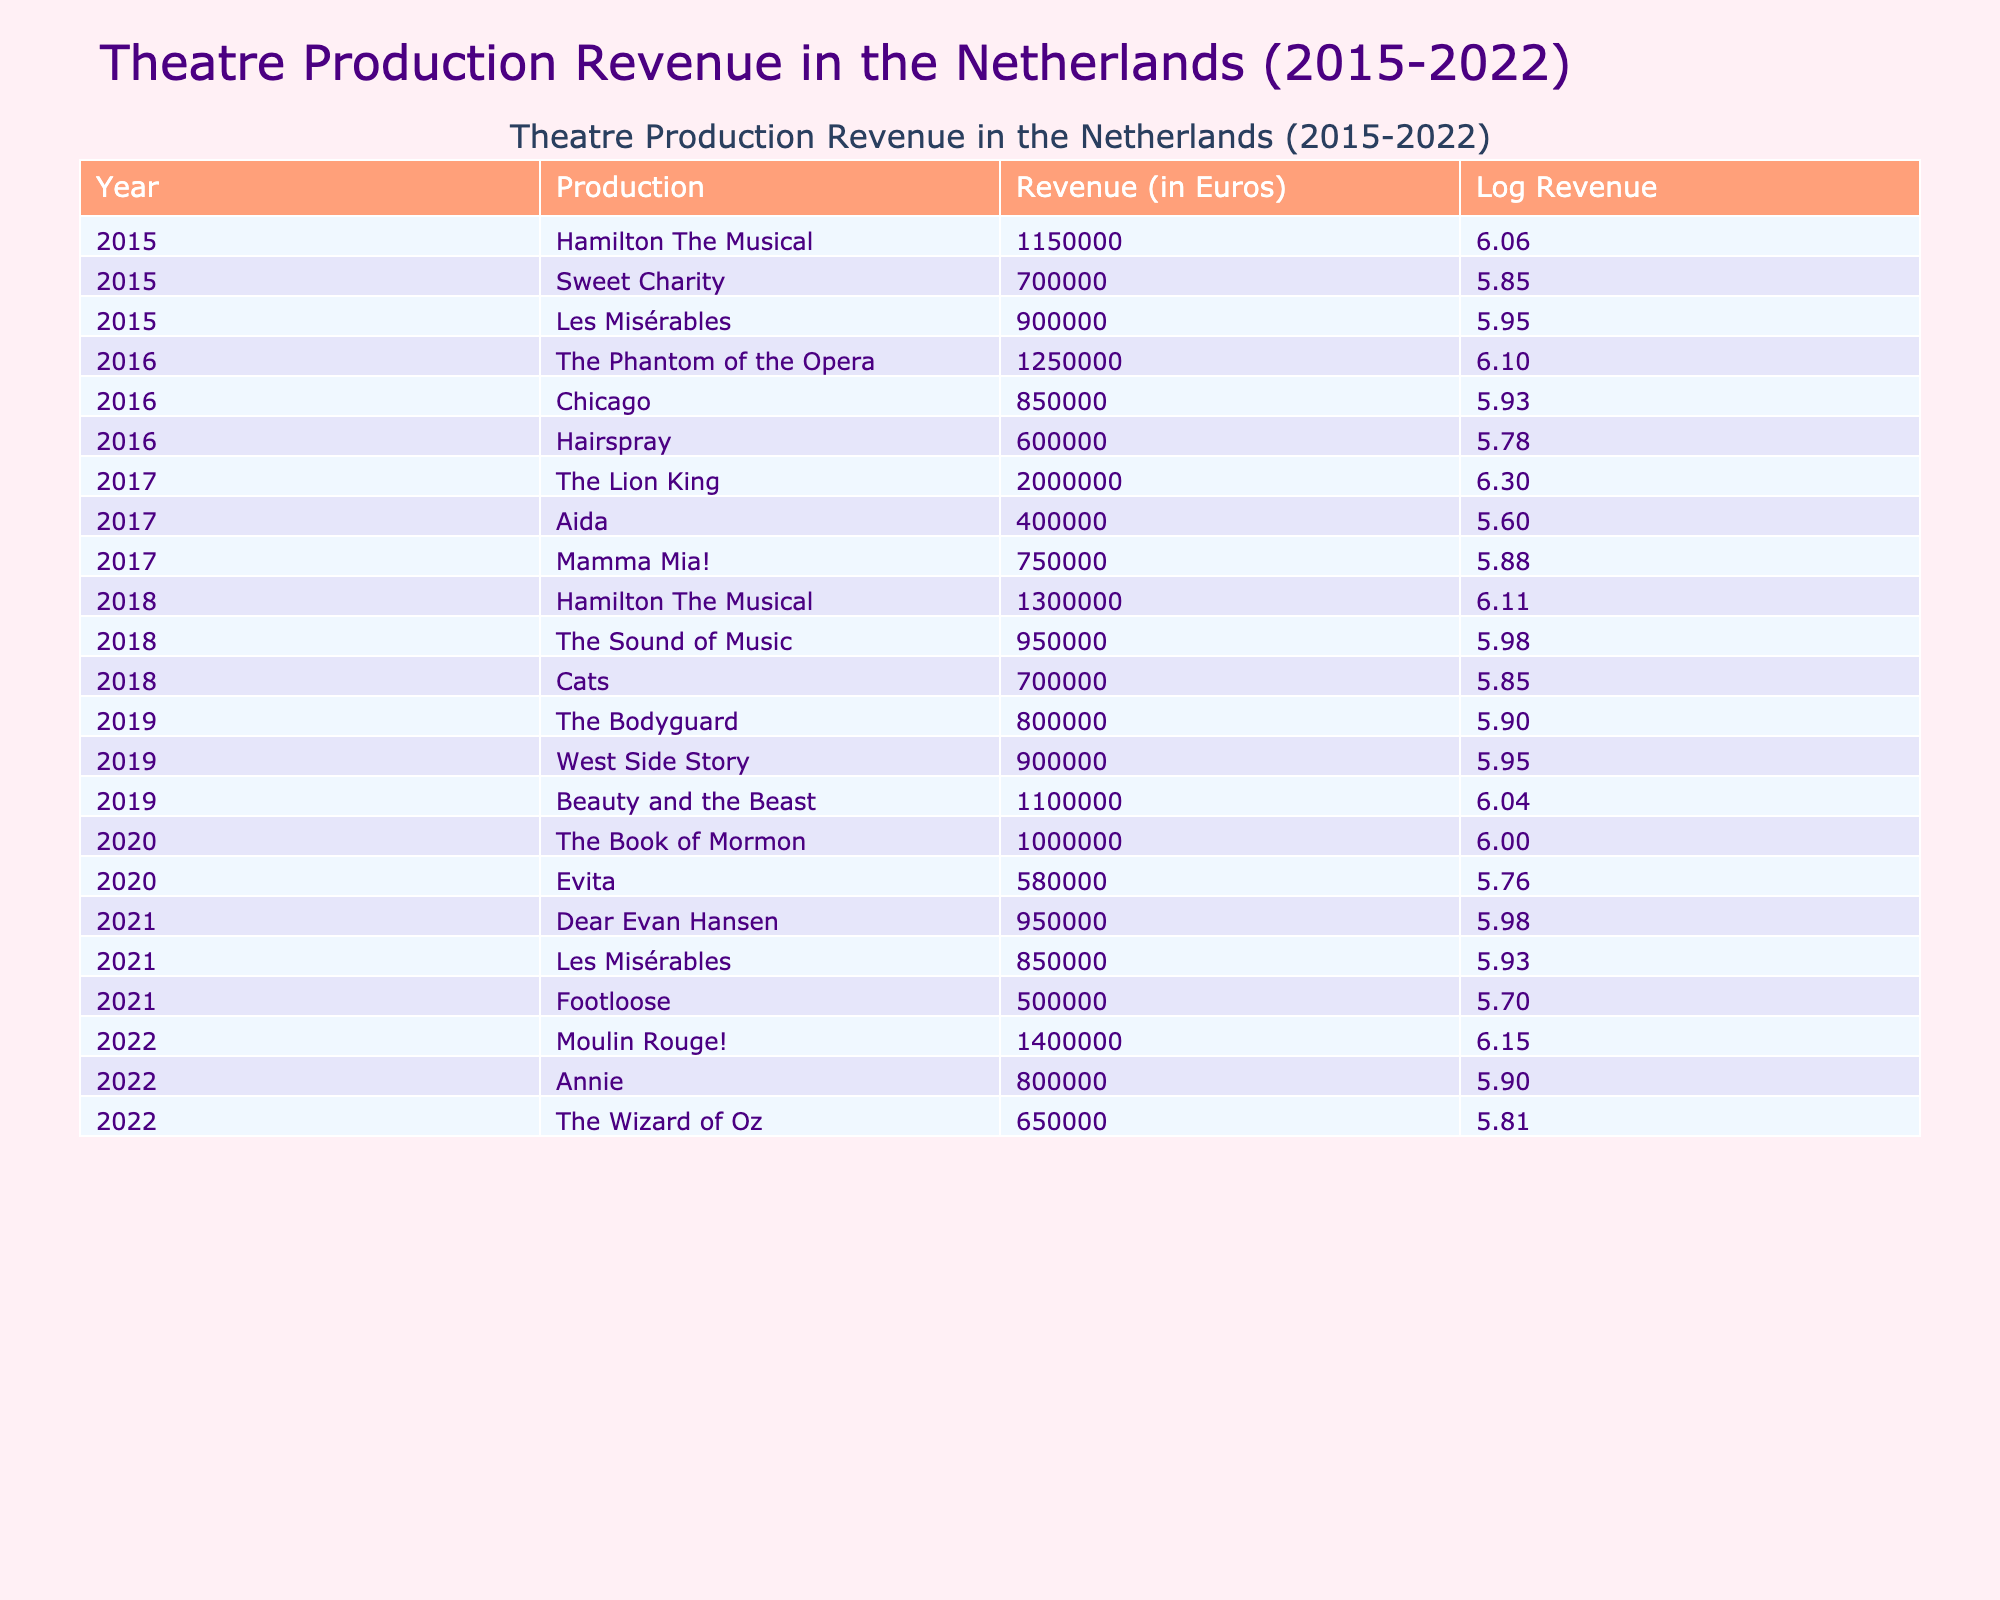What was the highest revenue generated by a single production in 2017? The productions listed for 2017 are The Lion King (2,000,000), Aida (400,000), and Mamma Mia! (750,000). The highest revenue among these is from The Lion King with 2,000,000 Euros.
Answer: 2,000,000 What was the total revenue generated from all productions in 2019? The productions in 2019 and their revenues are The Bodyguard (800,000), West Side Story (900,000), and Beauty and the Beast (1,100,000). Adding these together: 800,000 + 900,000 + 1,100,000 = 2,800,000 Euros.
Answer: 2,800,000 Which year had the lowest revenue from a single production? In 2015, Sweet Charity generated the lowest revenue with 700,000 Euros compared to all other listed productions in any year.
Answer: 700,000 Was the revenue of Les Misérables consistent over the years it was performed? Les Misérables was performed in 2015 (900,000), 2021 (850,000), and the revenue changed slightly between the two years, thus it was not consistent.
Answer: No What is the average revenue for productions in 2020? The productions for 2020 are The Book of Mormon (1,000,000) and Evita (580,000). The average revenue is calculated as (1,000,000 + 580,000) / 2 = 790,000 Euros.
Answer: 790,000 Which production had the largest increase in revenue from 2015 to 2018? For Hamilton The Musical, the revenue increased from 1,150,000 in 2015 to 1,300,000 in 2018. For other productions, no increase matches this. The increase is calculated as 1,300,000 - 1,150,000 = 150,000.
Answer: 150,000 How many productions generated over 1 million Euros in 2022? The productions in 2022 are Moulin Rouge! (1,400,000), Annie (800,000), and The Wizard of Oz (650,000). Only Moulin Rouge! generated over 1 million Euros.
Answer: 1 What was the total revenue difference between 2016 and 2017? Total revenue for 2016 was 1250000 + 850000 + 600000 = 2,800,000 Euros. For 2017, it was 2,000,000 + 400,000 + 750,000 = 3,150,000 Euros. The difference is 3,150,000 - 2,800,000 = 350,000 Euros.
Answer: 350,000 Which production had the highest revenue in 2021? In 2021, the productions listed are Dear Evan Hansen (950,000), Les Misérables (850,000), and Footloose (500,000). The highest revenue is from Dear Evan Hansen.
Answer: Dear Evan Hansen 